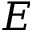<formula> <loc_0><loc_0><loc_500><loc_500>E</formula> 